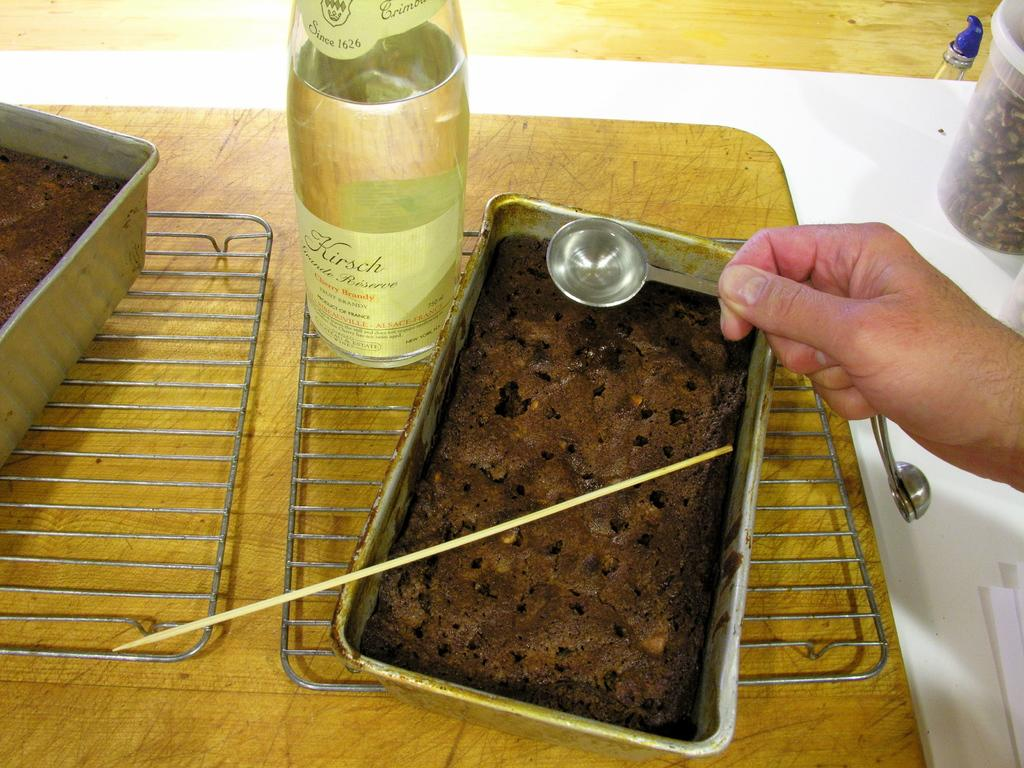What is inside the container that can be seen in the image? There is food in a container in the image. Who is holding a spoon in the image? There is a man holding a spoon in the image. What else can be seen in the image besides the food and the man with a spoon? There is a jar in the image. What type of bubble is floating near the man in the image? There is no bubble present in the image. How does the man look at the food in the container? The image does not show the man's facial expression or how he is looking at the food. 